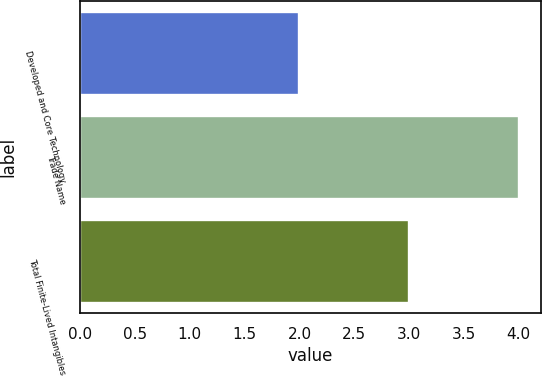<chart> <loc_0><loc_0><loc_500><loc_500><bar_chart><fcel>Developed and Core Technology<fcel>Trade Name<fcel>Total Finite-Lived Intangibles<nl><fcel>2<fcel>4<fcel>3<nl></chart> 